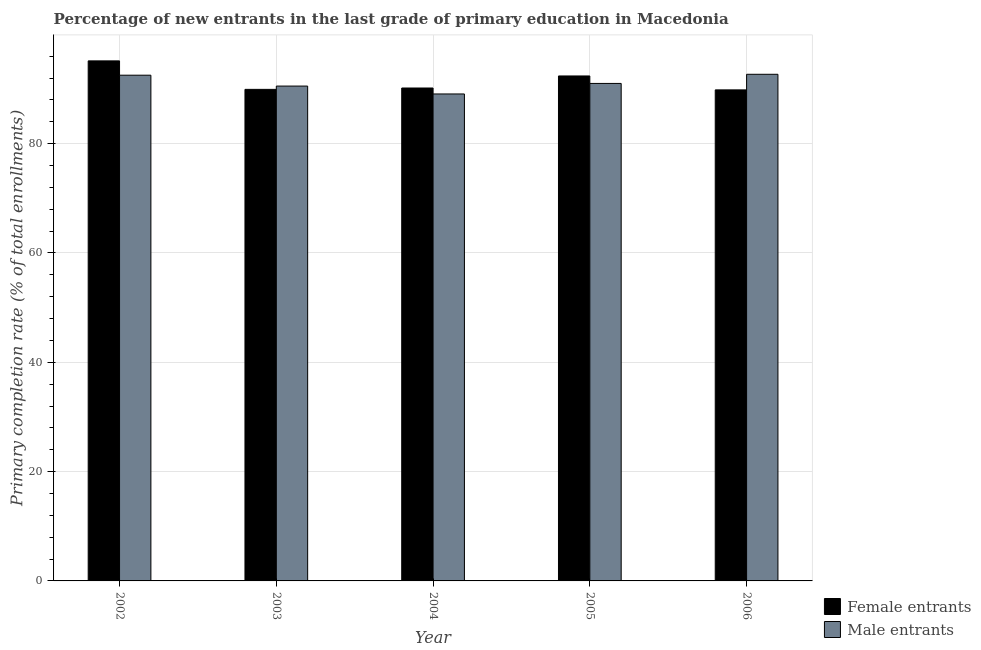How many different coloured bars are there?
Give a very brief answer. 2. How many groups of bars are there?
Give a very brief answer. 5. Are the number of bars per tick equal to the number of legend labels?
Your answer should be very brief. Yes. Are the number of bars on each tick of the X-axis equal?
Offer a terse response. Yes. How many bars are there on the 3rd tick from the right?
Give a very brief answer. 2. What is the primary completion rate of female entrants in 2002?
Ensure brevity in your answer.  95.15. Across all years, what is the maximum primary completion rate of female entrants?
Provide a succinct answer. 95.15. Across all years, what is the minimum primary completion rate of female entrants?
Your answer should be compact. 89.84. In which year was the primary completion rate of female entrants maximum?
Your answer should be very brief. 2002. What is the total primary completion rate of female entrants in the graph?
Provide a succinct answer. 457.5. What is the difference between the primary completion rate of female entrants in 2002 and that in 2005?
Give a very brief answer. 2.76. What is the difference between the primary completion rate of male entrants in 2002 and the primary completion rate of female entrants in 2004?
Ensure brevity in your answer.  3.43. What is the average primary completion rate of male entrants per year?
Make the answer very short. 91.18. What is the ratio of the primary completion rate of male entrants in 2004 to that in 2005?
Make the answer very short. 0.98. Is the primary completion rate of female entrants in 2004 less than that in 2006?
Provide a short and direct response. No. Is the difference between the primary completion rate of female entrants in 2002 and 2006 greater than the difference between the primary completion rate of male entrants in 2002 and 2006?
Offer a terse response. No. What is the difference between the highest and the second highest primary completion rate of female entrants?
Make the answer very short. 2.76. What is the difference between the highest and the lowest primary completion rate of female entrants?
Provide a short and direct response. 5.31. What does the 1st bar from the left in 2004 represents?
Give a very brief answer. Female entrants. What does the 1st bar from the right in 2003 represents?
Your answer should be compact. Male entrants. How many years are there in the graph?
Give a very brief answer. 5. Are the values on the major ticks of Y-axis written in scientific E-notation?
Offer a very short reply. No. Does the graph contain any zero values?
Make the answer very short. No. How many legend labels are there?
Keep it short and to the point. 2. What is the title of the graph?
Your answer should be compact. Percentage of new entrants in the last grade of primary education in Macedonia. Does "Death rate" appear as one of the legend labels in the graph?
Provide a short and direct response. No. What is the label or title of the X-axis?
Your answer should be compact. Year. What is the label or title of the Y-axis?
Your response must be concise. Primary completion rate (% of total enrollments). What is the Primary completion rate (% of total enrollments) of Female entrants in 2002?
Provide a succinct answer. 95.15. What is the Primary completion rate (% of total enrollments) of Male entrants in 2002?
Offer a terse response. 92.53. What is the Primary completion rate (% of total enrollments) in Female entrants in 2003?
Make the answer very short. 89.93. What is the Primary completion rate (% of total enrollments) in Male entrants in 2003?
Provide a succinct answer. 90.54. What is the Primary completion rate (% of total enrollments) in Female entrants in 2004?
Your response must be concise. 90.18. What is the Primary completion rate (% of total enrollments) in Male entrants in 2004?
Make the answer very short. 89.09. What is the Primary completion rate (% of total enrollments) in Female entrants in 2005?
Your answer should be compact. 92.39. What is the Primary completion rate (% of total enrollments) of Male entrants in 2005?
Offer a very short reply. 91.02. What is the Primary completion rate (% of total enrollments) in Female entrants in 2006?
Offer a very short reply. 89.84. What is the Primary completion rate (% of total enrollments) of Male entrants in 2006?
Your answer should be very brief. 92.69. Across all years, what is the maximum Primary completion rate (% of total enrollments) in Female entrants?
Your answer should be compact. 95.15. Across all years, what is the maximum Primary completion rate (% of total enrollments) of Male entrants?
Give a very brief answer. 92.69. Across all years, what is the minimum Primary completion rate (% of total enrollments) in Female entrants?
Your response must be concise. 89.84. Across all years, what is the minimum Primary completion rate (% of total enrollments) of Male entrants?
Offer a very short reply. 89.09. What is the total Primary completion rate (% of total enrollments) in Female entrants in the graph?
Your answer should be very brief. 457.5. What is the total Primary completion rate (% of total enrollments) of Male entrants in the graph?
Your answer should be compact. 455.88. What is the difference between the Primary completion rate (% of total enrollments) of Female entrants in 2002 and that in 2003?
Offer a very short reply. 5.21. What is the difference between the Primary completion rate (% of total enrollments) in Male entrants in 2002 and that in 2003?
Offer a terse response. 1.99. What is the difference between the Primary completion rate (% of total enrollments) in Female entrants in 2002 and that in 2004?
Offer a terse response. 4.96. What is the difference between the Primary completion rate (% of total enrollments) in Male entrants in 2002 and that in 2004?
Your response must be concise. 3.43. What is the difference between the Primary completion rate (% of total enrollments) of Female entrants in 2002 and that in 2005?
Your answer should be compact. 2.76. What is the difference between the Primary completion rate (% of total enrollments) of Male entrants in 2002 and that in 2005?
Provide a succinct answer. 1.51. What is the difference between the Primary completion rate (% of total enrollments) in Female entrants in 2002 and that in 2006?
Make the answer very short. 5.31. What is the difference between the Primary completion rate (% of total enrollments) of Male entrants in 2002 and that in 2006?
Provide a short and direct response. -0.16. What is the difference between the Primary completion rate (% of total enrollments) of Female entrants in 2003 and that in 2004?
Your answer should be compact. -0.25. What is the difference between the Primary completion rate (% of total enrollments) of Male entrants in 2003 and that in 2004?
Provide a succinct answer. 1.44. What is the difference between the Primary completion rate (% of total enrollments) in Female entrants in 2003 and that in 2005?
Your response must be concise. -2.45. What is the difference between the Primary completion rate (% of total enrollments) in Male entrants in 2003 and that in 2005?
Your answer should be compact. -0.48. What is the difference between the Primary completion rate (% of total enrollments) in Female entrants in 2003 and that in 2006?
Make the answer very short. 0.09. What is the difference between the Primary completion rate (% of total enrollments) in Male entrants in 2003 and that in 2006?
Keep it short and to the point. -2.15. What is the difference between the Primary completion rate (% of total enrollments) of Female entrants in 2004 and that in 2005?
Your answer should be compact. -2.2. What is the difference between the Primary completion rate (% of total enrollments) in Male entrants in 2004 and that in 2005?
Your answer should be compact. -1.93. What is the difference between the Primary completion rate (% of total enrollments) of Female entrants in 2004 and that in 2006?
Ensure brevity in your answer.  0.34. What is the difference between the Primary completion rate (% of total enrollments) of Male entrants in 2004 and that in 2006?
Your response must be concise. -3.6. What is the difference between the Primary completion rate (% of total enrollments) of Female entrants in 2005 and that in 2006?
Offer a very short reply. 2.55. What is the difference between the Primary completion rate (% of total enrollments) of Male entrants in 2005 and that in 2006?
Provide a short and direct response. -1.67. What is the difference between the Primary completion rate (% of total enrollments) in Female entrants in 2002 and the Primary completion rate (% of total enrollments) in Male entrants in 2003?
Keep it short and to the point. 4.61. What is the difference between the Primary completion rate (% of total enrollments) in Female entrants in 2002 and the Primary completion rate (% of total enrollments) in Male entrants in 2004?
Keep it short and to the point. 6.05. What is the difference between the Primary completion rate (% of total enrollments) in Female entrants in 2002 and the Primary completion rate (% of total enrollments) in Male entrants in 2005?
Offer a terse response. 4.13. What is the difference between the Primary completion rate (% of total enrollments) of Female entrants in 2002 and the Primary completion rate (% of total enrollments) of Male entrants in 2006?
Ensure brevity in your answer.  2.45. What is the difference between the Primary completion rate (% of total enrollments) in Female entrants in 2003 and the Primary completion rate (% of total enrollments) in Male entrants in 2004?
Keep it short and to the point. 0.84. What is the difference between the Primary completion rate (% of total enrollments) in Female entrants in 2003 and the Primary completion rate (% of total enrollments) in Male entrants in 2005?
Provide a succinct answer. -1.09. What is the difference between the Primary completion rate (% of total enrollments) of Female entrants in 2003 and the Primary completion rate (% of total enrollments) of Male entrants in 2006?
Give a very brief answer. -2.76. What is the difference between the Primary completion rate (% of total enrollments) in Female entrants in 2004 and the Primary completion rate (% of total enrollments) in Male entrants in 2005?
Make the answer very short. -0.84. What is the difference between the Primary completion rate (% of total enrollments) in Female entrants in 2004 and the Primary completion rate (% of total enrollments) in Male entrants in 2006?
Provide a succinct answer. -2.51. What is the difference between the Primary completion rate (% of total enrollments) in Female entrants in 2005 and the Primary completion rate (% of total enrollments) in Male entrants in 2006?
Your answer should be very brief. -0.3. What is the average Primary completion rate (% of total enrollments) of Female entrants per year?
Your answer should be compact. 91.5. What is the average Primary completion rate (% of total enrollments) in Male entrants per year?
Offer a very short reply. 91.18. In the year 2002, what is the difference between the Primary completion rate (% of total enrollments) in Female entrants and Primary completion rate (% of total enrollments) in Male entrants?
Offer a terse response. 2.62. In the year 2003, what is the difference between the Primary completion rate (% of total enrollments) of Female entrants and Primary completion rate (% of total enrollments) of Male entrants?
Give a very brief answer. -0.61. In the year 2004, what is the difference between the Primary completion rate (% of total enrollments) in Female entrants and Primary completion rate (% of total enrollments) in Male entrants?
Provide a short and direct response. 1.09. In the year 2005, what is the difference between the Primary completion rate (% of total enrollments) in Female entrants and Primary completion rate (% of total enrollments) in Male entrants?
Make the answer very short. 1.37. In the year 2006, what is the difference between the Primary completion rate (% of total enrollments) of Female entrants and Primary completion rate (% of total enrollments) of Male entrants?
Ensure brevity in your answer.  -2.85. What is the ratio of the Primary completion rate (% of total enrollments) of Female entrants in 2002 to that in 2003?
Offer a very short reply. 1.06. What is the ratio of the Primary completion rate (% of total enrollments) in Female entrants in 2002 to that in 2004?
Keep it short and to the point. 1.05. What is the ratio of the Primary completion rate (% of total enrollments) of Female entrants in 2002 to that in 2005?
Provide a succinct answer. 1.03. What is the ratio of the Primary completion rate (% of total enrollments) of Male entrants in 2002 to that in 2005?
Keep it short and to the point. 1.02. What is the ratio of the Primary completion rate (% of total enrollments) in Female entrants in 2002 to that in 2006?
Make the answer very short. 1.06. What is the ratio of the Primary completion rate (% of total enrollments) in Male entrants in 2002 to that in 2006?
Provide a short and direct response. 1. What is the ratio of the Primary completion rate (% of total enrollments) of Female entrants in 2003 to that in 2004?
Your response must be concise. 1. What is the ratio of the Primary completion rate (% of total enrollments) of Male entrants in 2003 to that in 2004?
Ensure brevity in your answer.  1.02. What is the ratio of the Primary completion rate (% of total enrollments) of Female entrants in 2003 to that in 2005?
Offer a very short reply. 0.97. What is the ratio of the Primary completion rate (% of total enrollments) of Male entrants in 2003 to that in 2005?
Provide a short and direct response. 0.99. What is the ratio of the Primary completion rate (% of total enrollments) in Female entrants in 2003 to that in 2006?
Keep it short and to the point. 1. What is the ratio of the Primary completion rate (% of total enrollments) in Male entrants in 2003 to that in 2006?
Keep it short and to the point. 0.98. What is the ratio of the Primary completion rate (% of total enrollments) of Female entrants in 2004 to that in 2005?
Make the answer very short. 0.98. What is the ratio of the Primary completion rate (% of total enrollments) of Male entrants in 2004 to that in 2005?
Offer a terse response. 0.98. What is the ratio of the Primary completion rate (% of total enrollments) of Female entrants in 2004 to that in 2006?
Provide a short and direct response. 1. What is the ratio of the Primary completion rate (% of total enrollments) of Male entrants in 2004 to that in 2006?
Your answer should be very brief. 0.96. What is the ratio of the Primary completion rate (% of total enrollments) of Female entrants in 2005 to that in 2006?
Your answer should be compact. 1.03. What is the ratio of the Primary completion rate (% of total enrollments) of Male entrants in 2005 to that in 2006?
Offer a terse response. 0.98. What is the difference between the highest and the second highest Primary completion rate (% of total enrollments) of Female entrants?
Your answer should be very brief. 2.76. What is the difference between the highest and the second highest Primary completion rate (% of total enrollments) of Male entrants?
Your answer should be very brief. 0.16. What is the difference between the highest and the lowest Primary completion rate (% of total enrollments) in Female entrants?
Your answer should be very brief. 5.31. What is the difference between the highest and the lowest Primary completion rate (% of total enrollments) in Male entrants?
Offer a very short reply. 3.6. 